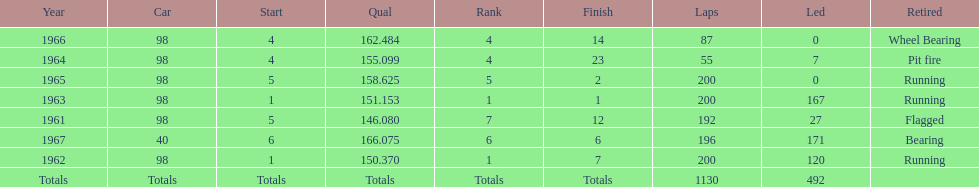How many times did he finish in the top three? 2. 